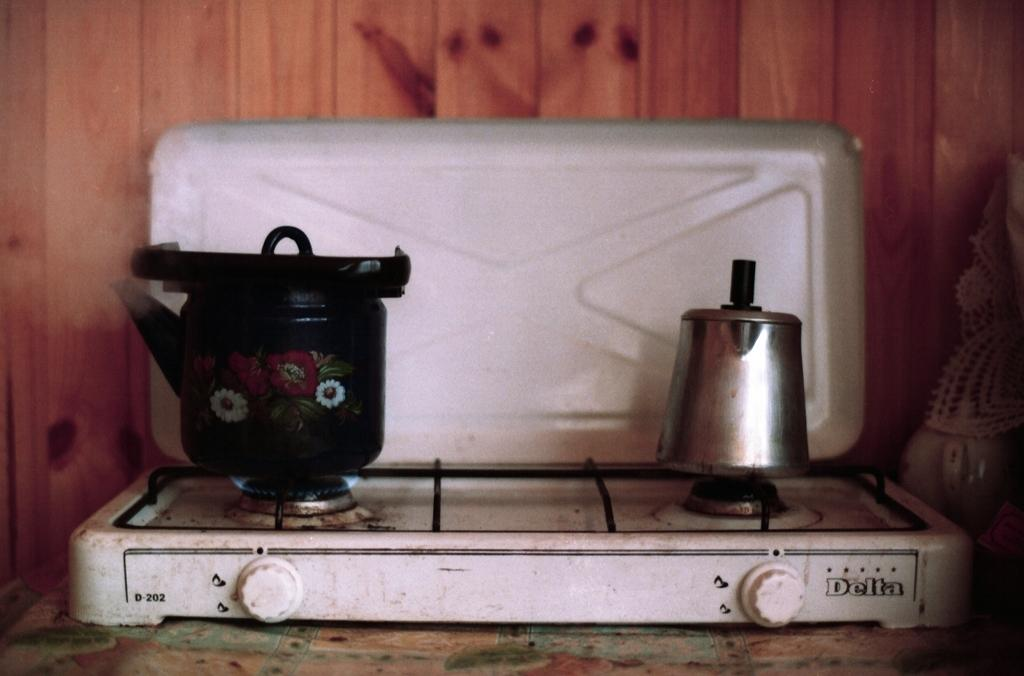<image>
Relay a brief, clear account of the picture shown. A small white hotplate is made by a company called Delta. 